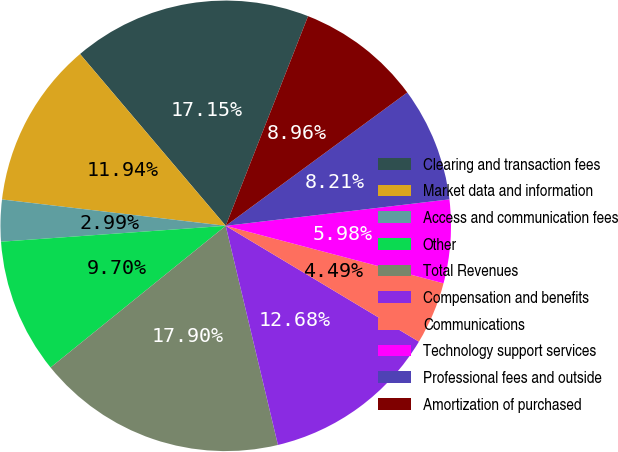Convert chart to OTSL. <chart><loc_0><loc_0><loc_500><loc_500><pie_chart><fcel>Clearing and transaction fees<fcel>Market data and information<fcel>Access and communication fees<fcel>Other<fcel>Total Revenues<fcel>Compensation and benefits<fcel>Communications<fcel>Technology support services<fcel>Professional fees and outside<fcel>Amortization of purchased<nl><fcel>17.15%<fcel>11.94%<fcel>2.99%<fcel>9.7%<fcel>17.9%<fcel>12.68%<fcel>4.49%<fcel>5.98%<fcel>8.21%<fcel>8.96%<nl></chart> 